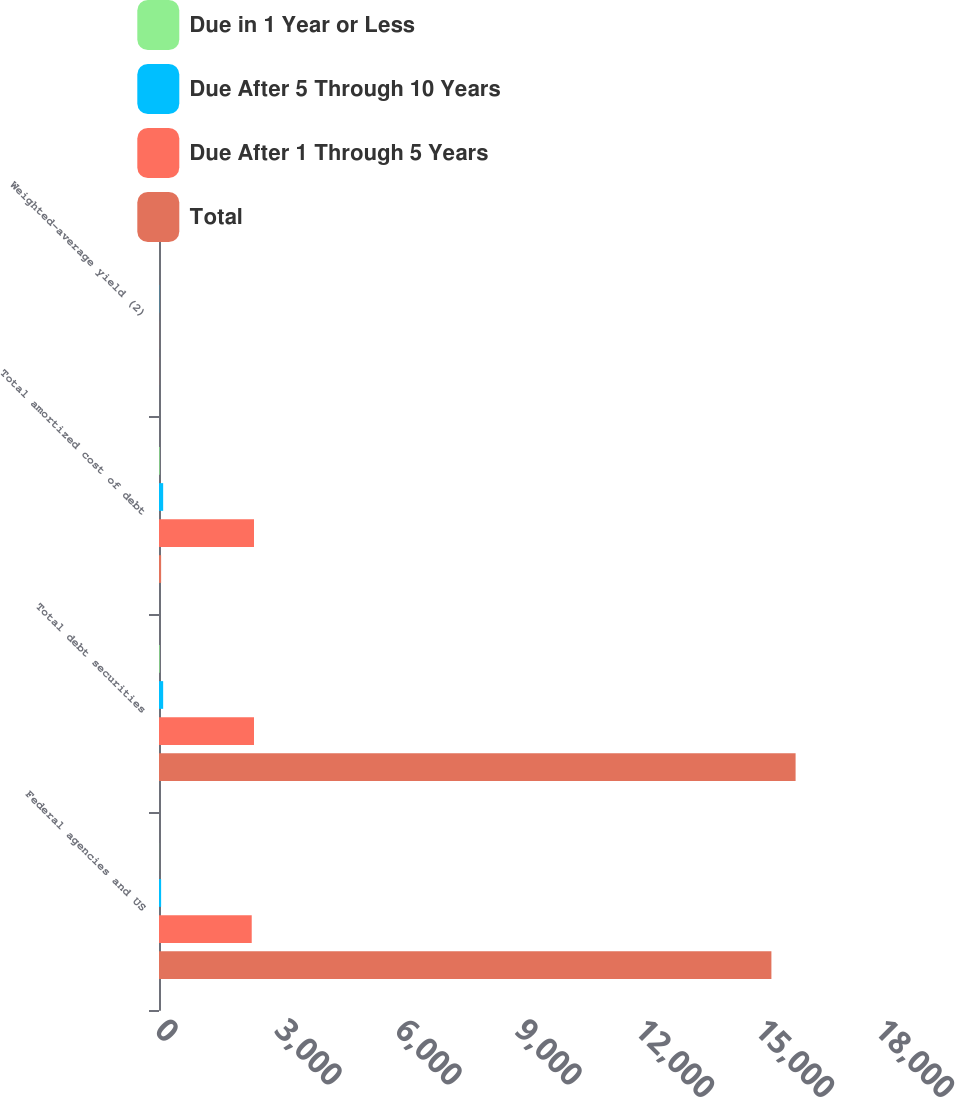<chart> <loc_0><loc_0><loc_500><loc_500><stacked_bar_chart><ecel><fcel>Federal agencies and US<fcel>Total debt securities<fcel>Total amortized cost of debt<fcel>Weighted-average yield (2)<nl><fcel>Due in 1 Year or Less<fcel>2<fcel>17<fcel>17<fcel>0.72<nl><fcel>Due After 5 Through 10 Years<fcel>53<fcel>104<fcel>104<fcel>4.77<nl><fcel>Due After 1 Through 5 Years<fcel>2318<fcel>2375<fcel>2375<fcel>1.76<nl><fcel>Total<fcel>15310<fcel>15915<fcel>53<fcel>2.74<nl></chart> 